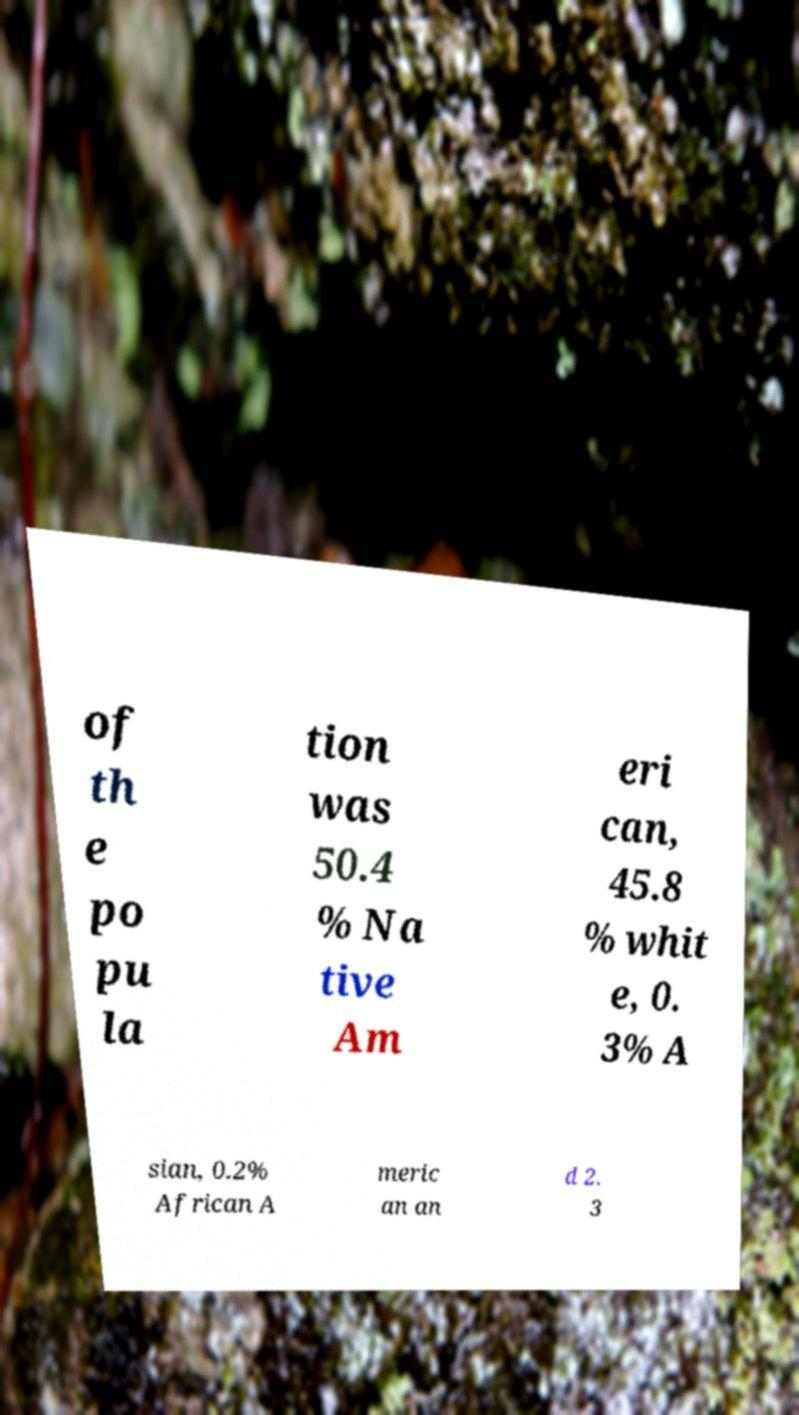What messages or text are displayed in this image? I need them in a readable, typed format. of th e po pu la tion was 50.4 % Na tive Am eri can, 45.8 % whit e, 0. 3% A sian, 0.2% African A meric an an d 2. 3 